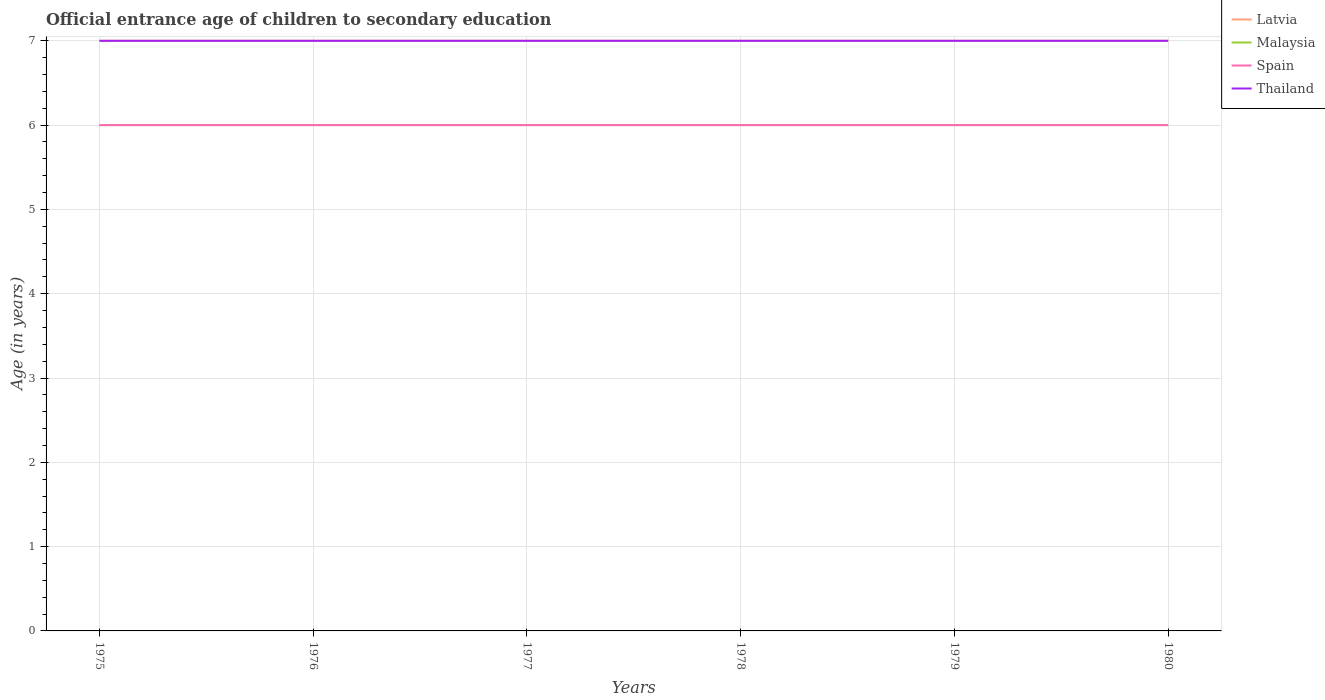In which year was the secondary school starting age of children in Thailand maximum?
Offer a terse response. 1975. What is the total secondary school starting age of children in Spain in the graph?
Your answer should be very brief. 0. What is the difference between the highest and the second highest secondary school starting age of children in Thailand?
Offer a very short reply. 0. Is the secondary school starting age of children in Malaysia strictly greater than the secondary school starting age of children in Latvia over the years?
Offer a very short reply. Yes. How many lines are there?
Offer a terse response. 4. How many years are there in the graph?
Provide a short and direct response. 6. How many legend labels are there?
Provide a succinct answer. 4. How are the legend labels stacked?
Ensure brevity in your answer.  Vertical. What is the title of the graph?
Provide a short and direct response. Official entrance age of children to secondary education. What is the label or title of the X-axis?
Keep it short and to the point. Years. What is the label or title of the Y-axis?
Offer a terse response. Age (in years). What is the Age (in years) in Latvia in 1975?
Your answer should be compact. 7. What is the Age (in years) of Thailand in 1975?
Offer a very short reply. 7. What is the Age (in years) in Latvia in 1976?
Provide a succinct answer. 7. What is the Age (in years) in Spain in 1976?
Your response must be concise. 6. What is the Age (in years) in Latvia in 1978?
Ensure brevity in your answer.  7. What is the Age (in years) in Malaysia in 1978?
Give a very brief answer. 6. What is the Age (in years) in Spain in 1978?
Ensure brevity in your answer.  6. What is the Age (in years) in Malaysia in 1979?
Provide a short and direct response. 6. What is the Age (in years) in Latvia in 1980?
Your answer should be very brief. 7. What is the Age (in years) in Spain in 1980?
Your answer should be very brief. 6. Across all years, what is the maximum Age (in years) in Latvia?
Your response must be concise. 7. Across all years, what is the maximum Age (in years) of Malaysia?
Provide a short and direct response. 6. Across all years, what is the maximum Age (in years) in Thailand?
Give a very brief answer. 7. Across all years, what is the minimum Age (in years) in Latvia?
Provide a succinct answer. 7. Across all years, what is the minimum Age (in years) in Spain?
Provide a short and direct response. 6. Across all years, what is the minimum Age (in years) of Thailand?
Offer a very short reply. 7. What is the total Age (in years) in Spain in the graph?
Give a very brief answer. 36. What is the total Age (in years) of Thailand in the graph?
Make the answer very short. 42. What is the difference between the Age (in years) in Latvia in 1975 and that in 1976?
Provide a short and direct response. 0. What is the difference between the Age (in years) of Malaysia in 1975 and that in 1976?
Provide a short and direct response. 0. What is the difference between the Age (in years) of Malaysia in 1975 and that in 1977?
Ensure brevity in your answer.  0. What is the difference between the Age (in years) in Spain in 1975 and that in 1977?
Make the answer very short. 0. What is the difference between the Age (in years) in Thailand in 1975 and that in 1977?
Your response must be concise. 0. What is the difference between the Age (in years) of Latvia in 1975 and that in 1978?
Keep it short and to the point. 0. What is the difference between the Age (in years) in Spain in 1975 and that in 1978?
Your answer should be compact. 0. What is the difference between the Age (in years) in Thailand in 1975 and that in 1978?
Your response must be concise. 0. What is the difference between the Age (in years) of Malaysia in 1975 and that in 1979?
Ensure brevity in your answer.  0. What is the difference between the Age (in years) of Spain in 1975 and that in 1979?
Make the answer very short. 0. What is the difference between the Age (in years) of Latvia in 1975 and that in 1980?
Give a very brief answer. 0. What is the difference between the Age (in years) of Spain in 1975 and that in 1980?
Keep it short and to the point. 0. What is the difference between the Age (in years) of Thailand in 1975 and that in 1980?
Provide a short and direct response. 0. What is the difference between the Age (in years) in Spain in 1976 and that in 1977?
Ensure brevity in your answer.  0. What is the difference between the Age (in years) of Thailand in 1976 and that in 1977?
Keep it short and to the point. 0. What is the difference between the Age (in years) of Latvia in 1976 and that in 1978?
Provide a succinct answer. 0. What is the difference between the Age (in years) of Malaysia in 1976 and that in 1978?
Your answer should be compact. 0. What is the difference between the Age (in years) in Latvia in 1976 and that in 1979?
Offer a terse response. 0. What is the difference between the Age (in years) in Malaysia in 1976 and that in 1979?
Ensure brevity in your answer.  0. What is the difference between the Age (in years) in Thailand in 1976 and that in 1979?
Keep it short and to the point. 0. What is the difference between the Age (in years) of Spain in 1976 and that in 1980?
Offer a very short reply. 0. What is the difference between the Age (in years) of Thailand in 1976 and that in 1980?
Ensure brevity in your answer.  0. What is the difference between the Age (in years) in Malaysia in 1977 and that in 1978?
Offer a very short reply. 0. What is the difference between the Age (in years) of Spain in 1977 and that in 1978?
Keep it short and to the point. 0. What is the difference between the Age (in years) in Latvia in 1977 and that in 1979?
Give a very brief answer. 0. What is the difference between the Age (in years) of Spain in 1977 and that in 1979?
Ensure brevity in your answer.  0. What is the difference between the Age (in years) in Thailand in 1977 and that in 1979?
Provide a short and direct response. 0. What is the difference between the Age (in years) in Spain in 1977 and that in 1980?
Your answer should be compact. 0. What is the difference between the Age (in years) in Malaysia in 1978 and that in 1979?
Give a very brief answer. 0. What is the difference between the Age (in years) of Thailand in 1978 and that in 1980?
Your answer should be very brief. 0. What is the difference between the Age (in years) of Malaysia in 1979 and that in 1980?
Offer a terse response. 0. What is the difference between the Age (in years) in Thailand in 1979 and that in 1980?
Offer a very short reply. 0. What is the difference between the Age (in years) in Latvia in 1975 and the Age (in years) in Malaysia in 1976?
Offer a very short reply. 1. What is the difference between the Age (in years) in Latvia in 1975 and the Age (in years) in Spain in 1976?
Offer a very short reply. 1. What is the difference between the Age (in years) in Malaysia in 1975 and the Age (in years) in Spain in 1976?
Your response must be concise. 0. What is the difference between the Age (in years) of Malaysia in 1975 and the Age (in years) of Thailand in 1976?
Ensure brevity in your answer.  -1. What is the difference between the Age (in years) in Spain in 1975 and the Age (in years) in Thailand in 1976?
Your answer should be very brief. -1. What is the difference between the Age (in years) in Spain in 1975 and the Age (in years) in Thailand in 1977?
Provide a succinct answer. -1. What is the difference between the Age (in years) in Latvia in 1975 and the Age (in years) in Malaysia in 1978?
Provide a succinct answer. 1. What is the difference between the Age (in years) of Latvia in 1975 and the Age (in years) of Thailand in 1978?
Offer a terse response. 0. What is the difference between the Age (in years) of Malaysia in 1975 and the Age (in years) of Spain in 1978?
Offer a very short reply. 0. What is the difference between the Age (in years) of Spain in 1975 and the Age (in years) of Thailand in 1978?
Offer a terse response. -1. What is the difference between the Age (in years) of Latvia in 1975 and the Age (in years) of Malaysia in 1979?
Your response must be concise. 1. What is the difference between the Age (in years) in Malaysia in 1975 and the Age (in years) in Spain in 1979?
Keep it short and to the point. 0. What is the difference between the Age (in years) in Malaysia in 1975 and the Age (in years) in Thailand in 1979?
Provide a short and direct response. -1. What is the difference between the Age (in years) of Latvia in 1975 and the Age (in years) of Thailand in 1980?
Provide a short and direct response. 0. What is the difference between the Age (in years) of Latvia in 1976 and the Age (in years) of Malaysia in 1977?
Offer a terse response. 1. What is the difference between the Age (in years) in Latvia in 1976 and the Age (in years) in Thailand in 1977?
Provide a short and direct response. 0. What is the difference between the Age (in years) of Malaysia in 1976 and the Age (in years) of Spain in 1978?
Offer a terse response. 0. What is the difference between the Age (in years) in Malaysia in 1976 and the Age (in years) in Thailand in 1978?
Keep it short and to the point. -1. What is the difference between the Age (in years) in Malaysia in 1976 and the Age (in years) in Spain in 1979?
Your answer should be compact. 0. What is the difference between the Age (in years) in Malaysia in 1976 and the Age (in years) in Thailand in 1979?
Your response must be concise. -1. What is the difference between the Age (in years) in Spain in 1976 and the Age (in years) in Thailand in 1979?
Offer a terse response. -1. What is the difference between the Age (in years) of Latvia in 1976 and the Age (in years) of Malaysia in 1980?
Offer a terse response. 1. What is the difference between the Age (in years) of Latvia in 1976 and the Age (in years) of Spain in 1980?
Your response must be concise. 1. What is the difference between the Age (in years) of Malaysia in 1976 and the Age (in years) of Spain in 1980?
Your answer should be compact. 0. What is the difference between the Age (in years) of Malaysia in 1976 and the Age (in years) of Thailand in 1980?
Offer a terse response. -1. What is the difference between the Age (in years) in Latvia in 1977 and the Age (in years) in Malaysia in 1978?
Your response must be concise. 1. What is the difference between the Age (in years) in Latvia in 1977 and the Age (in years) in Thailand in 1978?
Offer a terse response. 0. What is the difference between the Age (in years) in Malaysia in 1977 and the Age (in years) in Thailand in 1978?
Ensure brevity in your answer.  -1. What is the difference between the Age (in years) in Spain in 1977 and the Age (in years) in Thailand in 1978?
Provide a short and direct response. -1. What is the difference between the Age (in years) in Latvia in 1977 and the Age (in years) in Malaysia in 1979?
Your response must be concise. 1. What is the difference between the Age (in years) of Latvia in 1977 and the Age (in years) of Spain in 1979?
Provide a succinct answer. 1. What is the difference between the Age (in years) in Latvia in 1977 and the Age (in years) in Thailand in 1979?
Provide a short and direct response. 0. What is the difference between the Age (in years) of Spain in 1977 and the Age (in years) of Thailand in 1979?
Provide a short and direct response. -1. What is the difference between the Age (in years) of Latvia in 1977 and the Age (in years) of Malaysia in 1980?
Ensure brevity in your answer.  1. What is the difference between the Age (in years) of Latvia in 1977 and the Age (in years) of Thailand in 1980?
Your response must be concise. 0. What is the difference between the Age (in years) in Malaysia in 1977 and the Age (in years) in Thailand in 1980?
Offer a very short reply. -1. What is the difference between the Age (in years) in Latvia in 1978 and the Age (in years) in Malaysia in 1979?
Provide a short and direct response. 1. What is the difference between the Age (in years) of Malaysia in 1978 and the Age (in years) of Spain in 1979?
Your answer should be very brief. 0. What is the difference between the Age (in years) in Malaysia in 1978 and the Age (in years) in Thailand in 1979?
Keep it short and to the point. -1. What is the difference between the Age (in years) of Spain in 1978 and the Age (in years) of Thailand in 1979?
Your answer should be very brief. -1. What is the difference between the Age (in years) of Latvia in 1978 and the Age (in years) of Spain in 1980?
Ensure brevity in your answer.  1. What is the difference between the Age (in years) in Malaysia in 1978 and the Age (in years) in Thailand in 1980?
Your answer should be compact. -1. What is the difference between the Age (in years) of Latvia in 1979 and the Age (in years) of Spain in 1980?
Keep it short and to the point. 1. What is the difference between the Age (in years) in Latvia in 1979 and the Age (in years) in Thailand in 1980?
Your response must be concise. 0. What is the difference between the Age (in years) of Malaysia in 1979 and the Age (in years) of Spain in 1980?
Your answer should be very brief. 0. What is the difference between the Age (in years) of Malaysia in 1979 and the Age (in years) of Thailand in 1980?
Offer a terse response. -1. What is the difference between the Age (in years) of Spain in 1979 and the Age (in years) of Thailand in 1980?
Make the answer very short. -1. What is the average Age (in years) of Malaysia per year?
Your answer should be compact. 6. What is the average Age (in years) of Thailand per year?
Offer a terse response. 7. In the year 1975, what is the difference between the Age (in years) in Latvia and Age (in years) in Malaysia?
Your answer should be very brief. 1. In the year 1975, what is the difference between the Age (in years) in Latvia and Age (in years) in Thailand?
Your answer should be very brief. 0. In the year 1975, what is the difference between the Age (in years) in Malaysia and Age (in years) in Spain?
Provide a short and direct response. 0. In the year 1976, what is the difference between the Age (in years) of Latvia and Age (in years) of Thailand?
Make the answer very short. 0. In the year 1976, what is the difference between the Age (in years) of Malaysia and Age (in years) of Spain?
Your answer should be very brief. 0. In the year 1977, what is the difference between the Age (in years) of Latvia and Age (in years) of Malaysia?
Provide a succinct answer. 1. In the year 1977, what is the difference between the Age (in years) in Latvia and Age (in years) in Thailand?
Give a very brief answer. 0. In the year 1977, what is the difference between the Age (in years) of Malaysia and Age (in years) of Thailand?
Provide a succinct answer. -1. In the year 1977, what is the difference between the Age (in years) of Spain and Age (in years) of Thailand?
Offer a terse response. -1. In the year 1978, what is the difference between the Age (in years) in Latvia and Age (in years) in Thailand?
Your response must be concise. 0. In the year 1978, what is the difference between the Age (in years) in Malaysia and Age (in years) in Spain?
Make the answer very short. 0. In the year 1978, what is the difference between the Age (in years) of Spain and Age (in years) of Thailand?
Provide a succinct answer. -1. In the year 1979, what is the difference between the Age (in years) of Latvia and Age (in years) of Spain?
Provide a short and direct response. 1. In the year 1979, what is the difference between the Age (in years) of Latvia and Age (in years) of Thailand?
Offer a very short reply. 0. In the year 1979, what is the difference between the Age (in years) in Malaysia and Age (in years) in Thailand?
Offer a very short reply. -1. In the year 1979, what is the difference between the Age (in years) in Spain and Age (in years) in Thailand?
Offer a very short reply. -1. In the year 1980, what is the difference between the Age (in years) in Latvia and Age (in years) in Spain?
Ensure brevity in your answer.  1. In the year 1980, what is the difference between the Age (in years) in Malaysia and Age (in years) in Spain?
Make the answer very short. 0. In the year 1980, what is the difference between the Age (in years) of Malaysia and Age (in years) of Thailand?
Keep it short and to the point. -1. What is the ratio of the Age (in years) of Latvia in 1975 to that in 1976?
Ensure brevity in your answer.  1. What is the ratio of the Age (in years) in Spain in 1975 to that in 1976?
Provide a succinct answer. 1. What is the ratio of the Age (in years) in Latvia in 1975 to that in 1977?
Keep it short and to the point. 1. What is the ratio of the Age (in years) of Thailand in 1975 to that in 1977?
Your answer should be compact. 1. What is the ratio of the Age (in years) of Latvia in 1975 to that in 1978?
Your response must be concise. 1. What is the ratio of the Age (in years) of Malaysia in 1975 to that in 1979?
Your answer should be compact. 1. What is the ratio of the Age (in years) in Spain in 1975 to that in 1979?
Ensure brevity in your answer.  1. What is the ratio of the Age (in years) in Thailand in 1975 to that in 1979?
Provide a short and direct response. 1. What is the ratio of the Age (in years) of Malaysia in 1975 to that in 1980?
Provide a short and direct response. 1. What is the ratio of the Age (in years) of Spain in 1975 to that in 1980?
Keep it short and to the point. 1. What is the ratio of the Age (in years) in Latvia in 1976 to that in 1977?
Make the answer very short. 1. What is the ratio of the Age (in years) of Malaysia in 1976 to that in 1977?
Your answer should be very brief. 1. What is the ratio of the Age (in years) of Spain in 1976 to that in 1977?
Give a very brief answer. 1. What is the ratio of the Age (in years) in Thailand in 1976 to that in 1977?
Offer a very short reply. 1. What is the ratio of the Age (in years) of Malaysia in 1976 to that in 1978?
Make the answer very short. 1. What is the ratio of the Age (in years) in Spain in 1976 to that in 1978?
Ensure brevity in your answer.  1. What is the ratio of the Age (in years) in Malaysia in 1976 to that in 1979?
Provide a short and direct response. 1. What is the ratio of the Age (in years) in Latvia in 1976 to that in 1980?
Your response must be concise. 1. What is the ratio of the Age (in years) of Malaysia in 1976 to that in 1980?
Your response must be concise. 1. What is the ratio of the Age (in years) of Spain in 1976 to that in 1980?
Your answer should be compact. 1. What is the ratio of the Age (in years) of Thailand in 1976 to that in 1980?
Provide a succinct answer. 1. What is the ratio of the Age (in years) of Malaysia in 1977 to that in 1978?
Ensure brevity in your answer.  1. What is the ratio of the Age (in years) of Spain in 1977 to that in 1978?
Provide a short and direct response. 1. What is the ratio of the Age (in years) of Malaysia in 1977 to that in 1979?
Provide a short and direct response. 1. What is the ratio of the Age (in years) of Spain in 1977 to that in 1979?
Your answer should be very brief. 1. What is the ratio of the Age (in years) in Spain in 1977 to that in 1980?
Offer a terse response. 1. What is the ratio of the Age (in years) in Spain in 1978 to that in 1979?
Ensure brevity in your answer.  1. What is the ratio of the Age (in years) of Thailand in 1978 to that in 1979?
Offer a very short reply. 1. What is the ratio of the Age (in years) in Latvia in 1978 to that in 1980?
Make the answer very short. 1. What is the ratio of the Age (in years) of Malaysia in 1978 to that in 1980?
Offer a very short reply. 1. What is the ratio of the Age (in years) of Thailand in 1978 to that in 1980?
Ensure brevity in your answer.  1. What is the ratio of the Age (in years) of Malaysia in 1979 to that in 1980?
Offer a terse response. 1. What is the ratio of the Age (in years) in Spain in 1979 to that in 1980?
Offer a terse response. 1. What is the difference between the highest and the second highest Age (in years) of Spain?
Provide a short and direct response. 0. What is the difference between the highest and the lowest Age (in years) in Latvia?
Provide a succinct answer. 0. What is the difference between the highest and the lowest Age (in years) of Malaysia?
Your answer should be compact. 0. What is the difference between the highest and the lowest Age (in years) in Spain?
Make the answer very short. 0. 